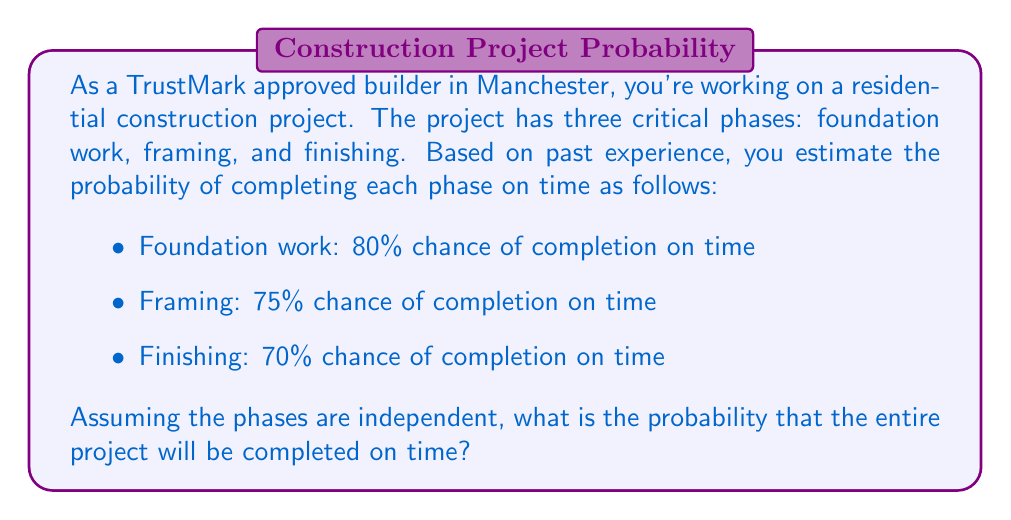Provide a solution to this math problem. To solve this problem, we need to consider the probability of all phases being completed on time. Since the phases are independent, we can multiply the individual probabilities.

Let's define the events:
$F$ = Foundation work completed on time
$R$ = Framing completed on time
$I$ = Finishing completed on time

We want to find $P(F \cap R \cap I)$, the probability of all three events occurring.

Given:
$P(F) = 0.80$
$P(R) = 0.75$
$P(I) = 0.70$

Since the events are independent:

$$P(F \cap R \cap I) = P(F) \times P(R) \times P(I)$$

Substituting the values:

$$P(F \cap R \cap I) = 0.80 \times 0.75 \times 0.70$$

$$P(F \cap R \cap I) = 0.42$$

Therefore, the probability of completing the entire project on time is 0.42 or 42%.
Answer: The probability of completing the entire construction project on time is 0.42 or 42%. 